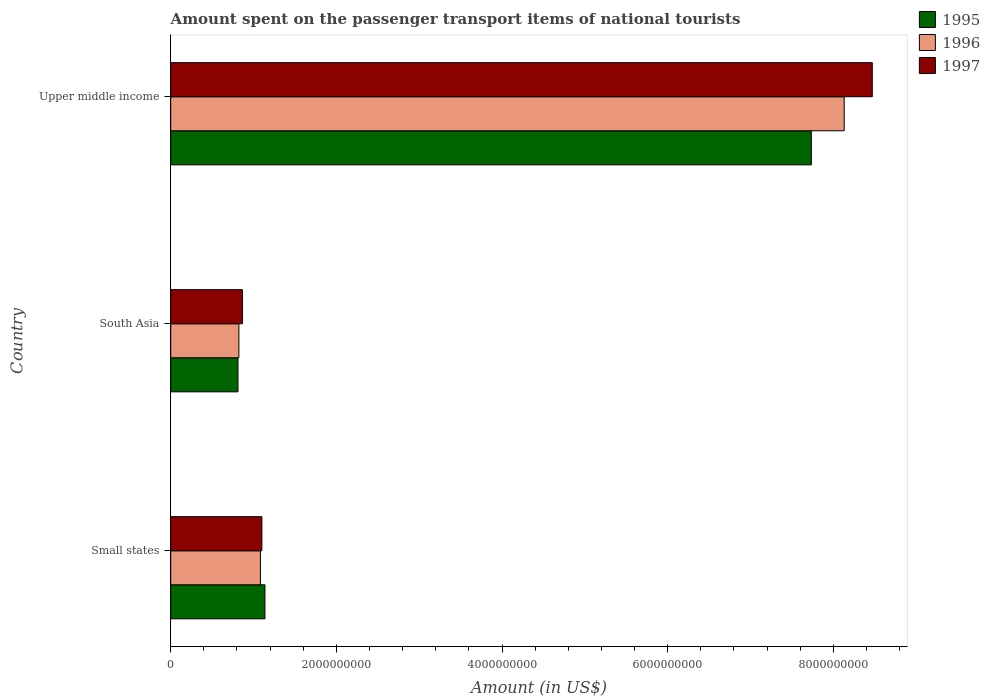How many different coloured bars are there?
Provide a short and direct response. 3. How many groups of bars are there?
Your answer should be compact. 3. Are the number of bars per tick equal to the number of legend labels?
Your answer should be compact. Yes. Are the number of bars on each tick of the Y-axis equal?
Your answer should be compact. Yes. What is the label of the 1st group of bars from the top?
Your answer should be very brief. Upper middle income. What is the amount spent on the passenger transport items of national tourists in 1995 in Small states?
Your response must be concise. 1.14e+09. Across all countries, what is the maximum amount spent on the passenger transport items of national tourists in 1996?
Keep it short and to the point. 8.13e+09. Across all countries, what is the minimum amount spent on the passenger transport items of national tourists in 1995?
Provide a short and direct response. 8.12e+08. In which country was the amount spent on the passenger transport items of national tourists in 1995 maximum?
Make the answer very short. Upper middle income. What is the total amount spent on the passenger transport items of national tourists in 1995 in the graph?
Provide a short and direct response. 9.68e+09. What is the difference between the amount spent on the passenger transport items of national tourists in 1996 in Small states and that in Upper middle income?
Offer a very short reply. -7.05e+09. What is the difference between the amount spent on the passenger transport items of national tourists in 1997 in Upper middle income and the amount spent on the passenger transport items of national tourists in 1996 in Small states?
Provide a succinct answer. 7.39e+09. What is the average amount spent on the passenger transport items of national tourists in 1997 per country?
Your response must be concise. 3.48e+09. What is the difference between the amount spent on the passenger transport items of national tourists in 1995 and amount spent on the passenger transport items of national tourists in 1996 in Upper middle income?
Offer a very short reply. -3.97e+08. In how many countries, is the amount spent on the passenger transport items of national tourists in 1995 greater than 6000000000 US$?
Your answer should be very brief. 1. What is the ratio of the amount spent on the passenger transport items of national tourists in 1995 in Small states to that in South Asia?
Your response must be concise. 1.4. Is the difference between the amount spent on the passenger transport items of national tourists in 1995 in South Asia and Upper middle income greater than the difference between the amount spent on the passenger transport items of national tourists in 1996 in South Asia and Upper middle income?
Your response must be concise. Yes. What is the difference between the highest and the second highest amount spent on the passenger transport items of national tourists in 1996?
Provide a short and direct response. 7.05e+09. What is the difference between the highest and the lowest amount spent on the passenger transport items of national tourists in 1995?
Your answer should be very brief. 6.92e+09. What does the 3rd bar from the top in South Asia represents?
Offer a terse response. 1995. What does the 3rd bar from the bottom in Small states represents?
Provide a succinct answer. 1997. What is the difference between two consecutive major ticks on the X-axis?
Make the answer very short. 2.00e+09. Does the graph contain any zero values?
Offer a terse response. No. How many legend labels are there?
Offer a very short reply. 3. How are the legend labels stacked?
Your answer should be compact. Vertical. What is the title of the graph?
Make the answer very short. Amount spent on the passenger transport items of national tourists. Does "1978" appear as one of the legend labels in the graph?
Provide a short and direct response. No. What is the label or title of the Y-axis?
Your answer should be very brief. Country. What is the Amount (in US$) of 1995 in Small states?
Your answer should be compact. 1.14e+09. What is the Amount (in US$) in 1996 in Small states?
Your answer should be compact. 1.08e+09. What is the Amount (in US$) in 1997 in Small states?
Provide a short and direct response. 1.10e+09. What is the Amount (in US$) in 1995 in South Asia?
Provide a succinct answer. 8.12e+08. What is the Amount (in US$) of 1996 in South Asia?
Provide a succinct answer. 8.23e+08. What is the Amount (in US$) of 1997 in South Asia?
Provide a short and direct response. 8.66e+08. What is the Amount (in US$) in 1995 in Upper middle income?
Give a very brief answer. 7.73e+09. What is the Amount (in US$) in 1996 in Upper middle income?
Your response must be concise. 8.13e+09. What is the Amount (in US$) in 1997 in Upper middle income?
Make the answer very short. 8.47e+09. Across all countries, what is the maximum Amount (in US$) of 1995?
Your response must be concise. 7.73e+09. Across all countries, what is the maximum Amount (in US$) of 1996?
Make the answer very short. 8.13e+09. Across all countries, what is the maximum Amount (in US$) in 1997?
Offer a very short reply. 8.47e+09. Across all countries, what is the minimum Amount (in US$) in 1995?
Offer a very short reply. 8.12e+08. Across all countries, what is the minimum Amount (in US$) in 1996?
Make the answer very short. 8.23e+08. Across all countries, what is the minimum Amount (in US$) in 1997?
Make the answer very short. 8.66e+08. What is the total Amount (in US$) in 1995 in the graph?
Offer a terse response. 9.68e+09. What is the total Amount (in US$) in 1996 in the graph?
Your answer should be compact. 1.00e+1. What is the total Amount (in US$) of 1997 in the graph?
Offer a terse response. 1.04e+1. What is the difference between the Amount (in US$) in 1995 in Small states and that in South Asia?
Your response must be concise. 3.25e+08. What is the difference between the Amount (in US$) in 1996 in Small states and that in South Asia?
Ensure brevity in your answer.  2.60e+08. What is the difference between the Amount (in US$) in 1997 in Small states and that in South Asia?
Your response must be concise. 2.35e+08. What is the difference between the Amount (in US$) in 1995 in Small states and that in Upper middle income?
Ensure brevity in your answer.  -6.60e+09. What is the difference between the Amount (in US$) of 1996 in Small states and that in Upper middle income?
Offer a very short reply. -7.05e+09. What is the difference between the Amount (in US$) of 1997 in Small states and that in Upper middle income?
Provide a short and direct response. -7.37e+09. What is the difference between the Amount (in US$) of 1995 in South Asia and that in Upper middle income?
Your answer should be very brief. -6.92e+09. What is the difference between the Amount (in US$) in 1996 in South Asia and that in Upper middle income?
Your answer should be very brief. -7.31e+09. What is the difference between the Amount (in US$) of 1997 in South Asia and that in Upper middle income?
Your answer should be compact. -7.60e+09. What is the difference between the Amount (in US$) in 1995 in Small states and the Amount (in US$) in 1996 in South Asia?
Your answer should be compact. 3.15e+08. What is the difference between the Amount (in US$) of 1995 in Small states and the Amount (in US$) of 1997 in South Asia?
Ensure brevity in your answer.  2.72e+08. What is the difference between the Amount (in US$) of 1996 in Small states and the Amount (in US$) of 1997 in South Asia?
Offer a very short reply. 2.18e+08. What is the difference between the Amount (in US$) of 1995 in Small states and the Amount (in US$) of 1996 in Upper middle income?
Ensure brevity in your answer.  -6.99e+09. What is the difference between the Amount (in US$) in 1995 in Small states and the Amount (in US$) in 1997 in Upper middle income?
Give a very brief answer. -7.33e+09. What is the difference between the Amount (in US$) in 1996 in Small states and the Amount (in US$) in 1997 in Upper middle income?
Offer a terse response. -7.39e+09. What is the difference between the Amount (in US$) in 1995 in South Asia and the Amount (in US$) in 1996 in Upper middle income?
Keep it short and to the point. -7.32e+09. What is the difference between the Amount (in US$) in 1995 in South Asia and the Amount (in US$) in 1997 in Upper middle income?
Your response must be concise. -7.66e+09. What is the difference between the Amount (in US$) in 1996 in South Asia and the Amount (in US$) in 1997 in Upper middle income?
Provide a short and direct response. -7.65e+09. What is the average Amount (in US$) in 1995 per country?
Keep it short and to the point. 3.23e+09. What is the average Amount (in US$) of 1996 per country?
Keep it short and to the point. 3.35e+09. What is the average Amount (in US$) in 1997 per country?
Give a very brief answer. 3.48e+09. What is the difference between the Amount (in US$) of 1995 and Amount (in US$) of 1996 in Small states?
Your answer should be very brief. 5.44e+07. What is the difference between the Amount (in US$) in 1995 and Amount (in US$) in 1997 in Small states?
Give a very brief answer. 3.69e+07. What is the difference between the Amount (in US$) of 1996 and Amount (in US$) of 1997 in Small states?
Make the answer very short. -1.75e+07. What is the difference between the Amount (in US$) in 1995 and Amount (in US$) in 1996 in South Asia?
Your response must be concise. -1.09e+07. What is the difference between the Amount (in US$) in 1995 and Amount (in US$) in 1997 in South Asia?
Provide a short and direct response. -5.35e+07. What is the difference between the Amount (in US$) of 1996 and Amount (in US$) of 1997 in South Asia?
Make the answer very short. -4.25e+07. What is the difference between the Amount (in US$) of 1995 and Amount (in US$) of 1996 in Upper middle income?
Your response must be concise. -3.97e+08. What is the difference between the Amount (in US$) in 1995 and Amount (in US$) in 1997 in Upper middle income?
Offer a very short reply. -7.36e+08. What is the difference between the Amount (in US$) in 1996 and Amount (in US$) in 1997 in Upper middle income?
Offer a terse response. -3.39e+08. What is the ratio of the Amount (in US$) of 1995 in Small states to that in South Asia?
Keep it short and to the point. 1.4. What is the ratio of the Amount (in US$) in 1996 in Small states to that in South Asia?
Your response must be concise. 1.32. What is the ratio of the Amount (in US$) in 1997 in Small states to that in South Asia?
Your response must be concise. 1.27. What is the ratio of the Amount (in US$) of 1995 in Small states to that in Upper middle income?
Your response must be concise. 0.15. What is the ratio of the Amount (in US$) in 1996 in Small states to that in Upper middle income?
Offer a terse response. 0.13. What is the ratio of the Amount (in US$) in 1997 in Small states to that in Upper middle income?
Provide a short and direct response. 0.13. What is the ratio of the Amount (in US$) in 1995 in South Asia to that in Upper middle income?
Ensure brevity in your answer.  0.1. What is the ratio of the Amount (in US$) of 1996 in South Asia to that in Upper middle income?
Ensure brevity in your answer.  0.1. What is the ratio of the Amount (in US$) in 1997 in South Asia to that in Upper middle income?
Offer a terse response. 0.1. What is the difference between the highest and the second highest Amount (in US$) in 1995?
Your answer should be compact. 6.60e+09. What is the difference between the highest and the second highest Amount (in US$) of 1996?
Make the answer very short. 7.05e+09. What is the difference between the highest and the second highest Amount (in US$) of 1997?
Your response must be concise. 7.37e+09. What is the difference between the highest and the lowest Amount (in US$) in 1995?
Your response must be concise. 6.92e+09. What is the difference between the highest and the lowest Amount (in US$) of 1996?
Offer a very short reply. 7.31e+09. What is the difference between the highest and the lowest Amount (in US$) in 1997?
Offer a terse response. 7.60e+09. 